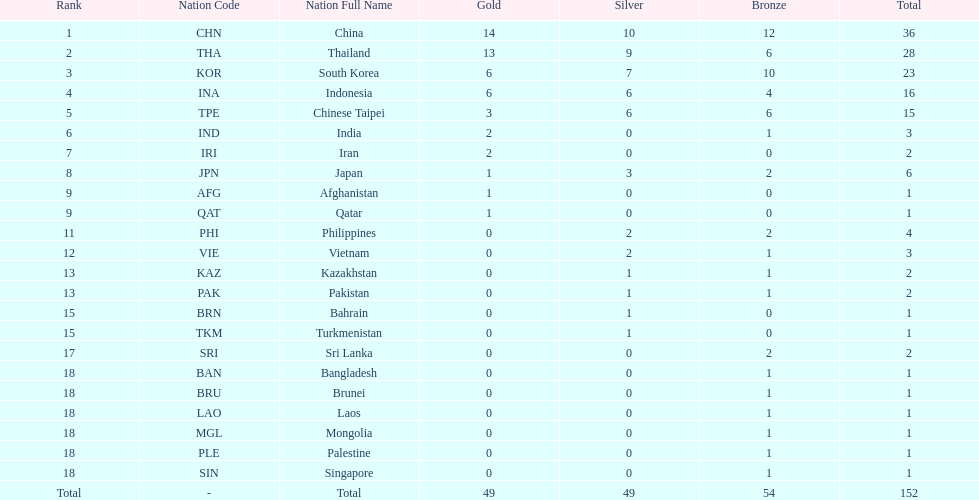Give me the full table as a dictionary. {'header': ['Rank', 'Nation Code', 'Nation Full Name', 'Gold', 'Silver', 'Bronze', 'Total'], 'rows': [['1', 'CHN', 'China', '14', '10', '12', '36'], ['2', 'THA', 'Thailand', '13', '9', '6', '28'], ['3', 'KOR', 'South Korea', '6', '7', '10', '23'], ['4', 'INA', 'Indonesia', '6', '6', '4', '16'], ['5', 'TPE', 'Chinese Taipei', '3', '6', '6', '15'], ['6', 'IND', 'India', '2', '0', '1', '3'], ['7', 'IRI', 'Iran', '2', '0', '0', '2'], ['8', 'JPN', 'Japan', '1', '3', '2', '6'], ['9', 'AFG', 'Afghanistan', '1', '0', '0', '1'], ['9', 'QAT', 'Qatar', '1', '0', '0', '1'], ['11', 'PHI', 'Philippines', '0', '2', '2', '4'], ['12', 'VIE', 'Vietnam', '0', '2', '1', '3'], ['13', 'KAZ', 'Kazakhstan', '0', '1', '1', '2'], ['13', 'PAK', 'Pakistan', '0', '1', '1', '2'], ['15', 'BRN', 'Bahrain', '0', '1', '0', '1'], ['15', 'TKM', 'Turkmenistan', '0', '1', '0', '1'], ['17', 'SRI', 'Sri Lanka', '0', '0', '2', '2'], ['18', 'BAN', 'Bangladesh', '0', '0', '1', '1'], ['18', 'BRU', 'Brunei', '0', '0', '1', '1'], ['18', 'LAO', 'Laos', '0', '0', '1', '1'], ['18', 'MGL', 'Mongolia', '0', '0', '1', '1'], ['18', 'PLE', 'Palestine', '0', '0', '1', '1'], ['18', 'SIN', 'Singapore', '0', '0', '1', '1'], ['Total', '-', 'Total', '49', '49', '54', '152']]} How many nations won no silver medals at all? 11. 